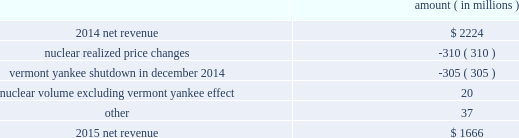Entergy corporation and subsidiaries management 2019s financial discussion and analysis the volume/weather variance is primarily due to an increase of 1402 gwh , or 1% ( 1 % ) , in billed electricity usage , including an increase in industrial usage and the effect of more favorable weather .
The increase in industrial sales was primarily due to expansion in the chemicals industry and the addition of new customers , partially offset by decreased demand primarily due to extended maintenance outages for existing chemicals customers .
The waterford 3 replacement steam generator provision is due to a regulatory charge of approximately $ 32 million recorded in 2015 related to the uncertainty associated with the resolution of the waterford 3 replacement steam generator project .
See note 2 to the financial statements for a discussion of the waterford 3 replacement steam generator prudence review proceeding .
The miso deferral variance is primarily due to the deferral in 2014 of non-fuel miso-related charges , as approved by the lpsc and the mpsc .
The deferral of non-fuel miso-related charges is partially offset in other operation and maintenance expenses .
See note 2 to the financial statements for further discussion of the recovery of non-fuel miso-related charges .
The louisiana business combination customer credits variance is due to a regulatory liability of $ 107 million recorded by entergy in october 2015 as a result of the entergy gulf states louisiana and entergy louisiana business combination .
Consistent with the terms of the stipulated settlement in the business combination proceeding , electric customers of entergy louisiana will realize customer credits associated with the business combination ; accordingly , in october 2015 , entergy recorded a regulatory liability of $ 107 million ( $ 66 million net-of-tax ) .
See note 2 to the financial statements for further discussion of the business combination and customer credits .
Entergy wholesale commodities following is an analysis of the change in net revenue comparing 2015 to 2014 .
Amount ( in millions ) .
As shown in the table above , net revenue for entergy wholesale commodities decreased by approximately $ 558 million in 2016 primarily due to : 2022 lower realized wholesale energy prices , primarily due to significantly higher northeast market power prices in 2014 , and lower capacity prices in 2015 ; and 2022 a decrease in net revenue as a result of vermont yankee ceasing power production in december 2014 .
The decrease was partially offset by higher volume in the entergy wholesale commodities nuclear fleet , excluding vermont yankee , resulting from fewer refueling outage days in 2015 as compared to 2014 , partially offset by more unplanned outage days in 2015 as compared to 2014. .
Was the tax benefit from the the stipulated settlement in the business combination granting customer credits greater than the change in revenue between years? 
Computations: ((107 - 66) > (2224 - 1666))
Answer: no. 